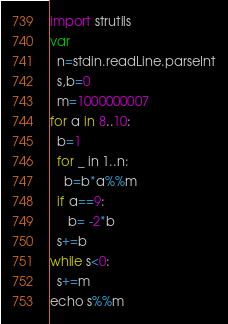Convert code to text. <code><loc_0><loc_0><loc_500><loc_500><_Nim_>import strutils
var
  n=stdin.readLine.parseInt
  s,b=0
  m=1000000007
for a in 8..10:
  b=1
  for _ in 1..n:
    b=b*a%%m
  if a==9:
     b= -2*b
  s+=b
while s<0:
  s+=m
echo s%%m</code> 